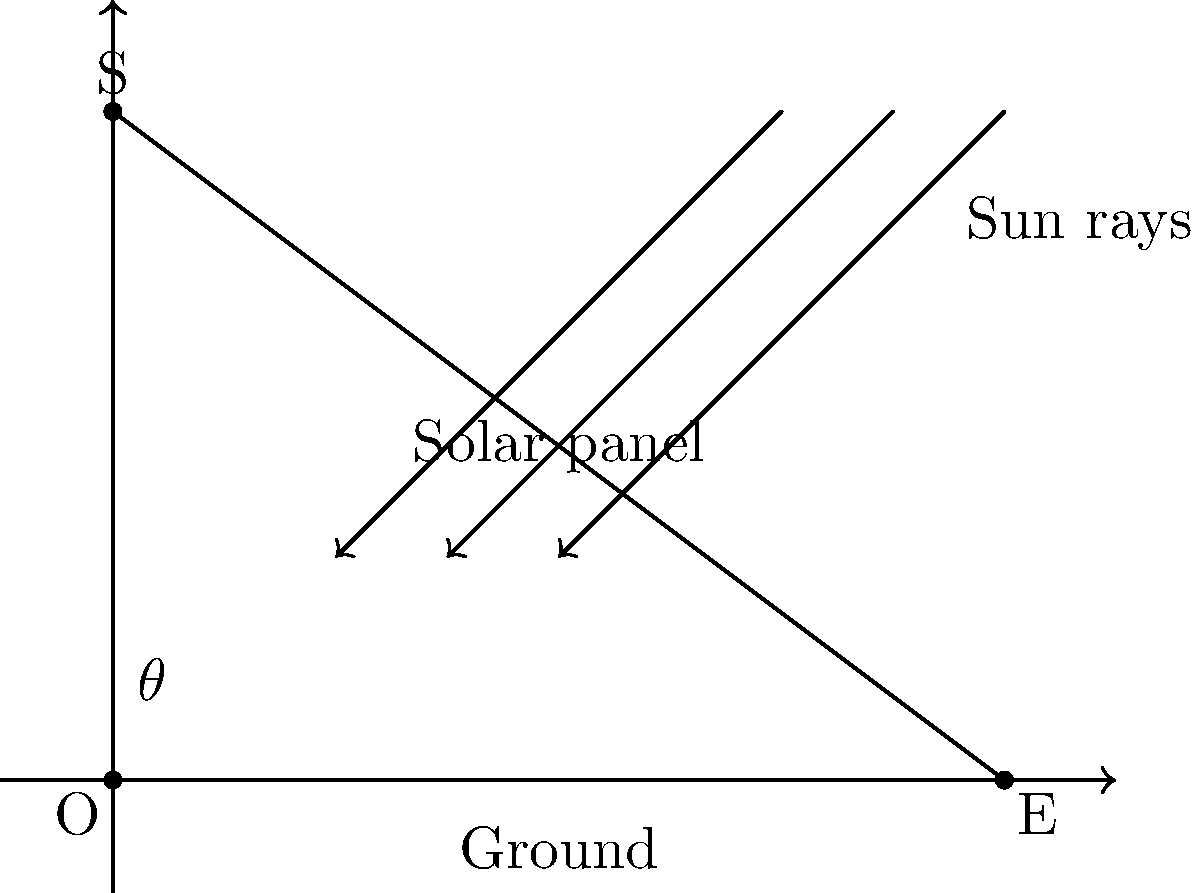Consider a solar panel installed at an angle $\theta$ with respect to the ground, as shown in the diagram. Given that the optimal angle of inclination for maximum energy absorption varies with latitude, which of the following statements is true for locations in the Northern Hemisphere?

A) The optimal angle $\theta$ is always equal to the latitude of the location.
B) The optimal angle $\theta$ should be adjusted seasonally, higher in winter and lower in summer.
C) The optimal angle $\theta$ should be fixed at 45° regardless of latitude.
D) The optimal angle $\theta$ decreases as you move closer to the equator. To determine the correct answer, let's consider the factors affecting the optimal angle of inclination for solar panels:

1. Solar panel efficiency depends on the angle at which sunlight hits the panel surface. Maximum efficiency is achieved when sunlight is perpendicular to the panel.

2. The sun's position in the sky changes throughout the year due to the Earth's axial tilt and orbital motion.

3. The sun's average position in the sky varies with latitude. It appears lower in the sky at higher latitudes and higher in the sky near the equator.

4. In the Northern Hemisphere, the sun is generally lower in the sky during winter and higher during summer.

Given these factors:

- Statement A is incorrect because while the latitude is a good starting point, it's not always the optimal angle year-round.

- Statement B is correct. Adjusting the angle seasonally accounts for the changing position of the sun throughout the year. A higher angle in winter compensates for the lower sun position, while a lower angle in summer is better suited for the higher sun position.

- Statement C is incorrect as a fixed 45° angle would not be optimal for all latitudes and seasons.

- Statement D is partially correct but incomplete. While the optimal angle generally decreases closer to the equator, this statement doesn't account for seasonal variations.

Therefore, the most accurate and complete statement is B.
Answer: B) The optimal angle $\theta$ should be adjusted seasonally, higher in winter and lower in summer. 